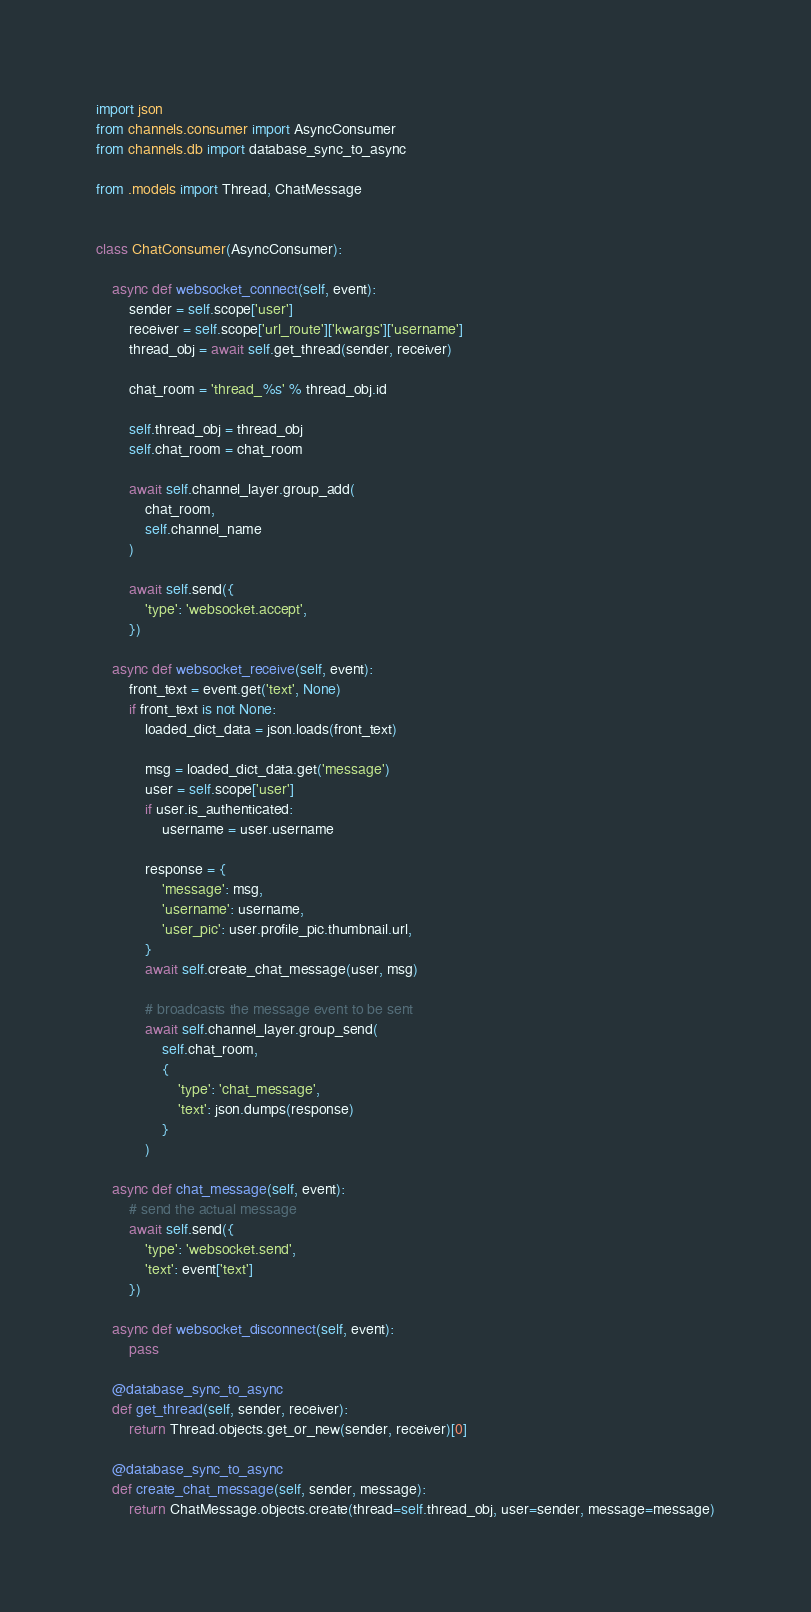Convert code to text. <code><loc_0><loc_0><loc_500><loc_500><_Python_>import json
from channels.consumer import AsyncConsumer
from channels.db import database_sync_to_async

from .models import Thread, ChatMessage


class ChatConsumer(AsyncConsumer):

    async def websocket_connect(self, event):
        sender = self.scope['user']
        receiver = self.scope['url_route']['kwargs']['username']
        thread_obj = await self.get_thread(sender, receiver)

        chat_room = 'thread_%s' % thread_obj.id

        self.thread_obj = thread_obj
        self.chat_room = chat_room

        await self.channel_layer.group_add(
            chat_room,
            self.channel_name
        )

        await self.send({
            'type': 'websocket.accept',
        })

    async def websocket_receive(self, event):
        front_text = event.get('text', None)
        if front_text is not None:
            loaded_dict_data = json.loads(front_text)

            msg = loaded_dict_data.get('message')
            user = self.scope['user']
            if user.is_authenticated:
                username = user.username

            response = {
                'message': msg,
                'username': username,
                'user_pic': user.profile_pic.thumbnail.url,
            }
            await self.create_chat_message(user, msg)

            # broadcasts the message event to be sent
            await self.channel_layer.group_send(
                self.chat_room,
                {
                    'type': 'chat_message',
                    'text': json.dumps(response)
                }
            )

    async def chat_message(self, event):
        # send the actual message
        await self.send({
            'type': 'websocket.send',
            'text': event['text']
        })

    async def websocket_disconnect(self, event):
        pass

    @database_sync_to_async
    def get_thread(self, sender, receiver):
        return Thread.objects.get_or_new(sender, receiver)[0]

    @database_sync_to_async
    def create_chat_message(self, sender, message):
        return ChatMessage.objects.create(thread=self.thread_obj, user=sender, message=message)
</code> 